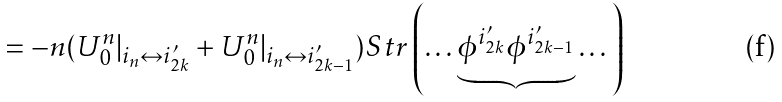Convert formula to latex. <formula><loc_0><loc_0><loc_500><loc_500>= - n ( U _ { 0 } ^ { n } | _ { i _ { n } \leftrightarrow i _ { 2 k } ^ { \prime } } + U _ { 0 } ^ { n } | _ { i _ { n } \leftrightarrow i _ { 2 k - 1 } ^ { \prime } } ) S t r \left ( \dots \underbrace { \phi ^ { i _ { 2 k } ^ { \prime } } \phi ^ { i _ { 2 k - 1 } ^ { \prime } } } \dots \right )</formula> 